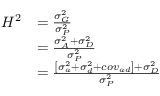<formula> <loc_0><loc_0><loc_500><loc_500>{ \begin{array} { r l } { H ^ { 2 } } & { = { \frac { \sigma _ { G } ^ { 2 } } { \sigma _ { P } ^ { 2 } } } } \\ & { = { \frac { \sigma _ { A } ^ { 2 } + \sigma _ { D } ^ { 2 } } { \sigma _ { P } ^ { 2 } } } } \\ & { = { \frac { \left [ \sigma _ { a } ^ { 2 } + \sigma _ { d } ^ { 2 } + c o v _ { a d } \right ] + \sigma _ { D } ^ { 2 } } { \sigma _ { P } ^ { 2 } } } } \end{array} }</formula> 